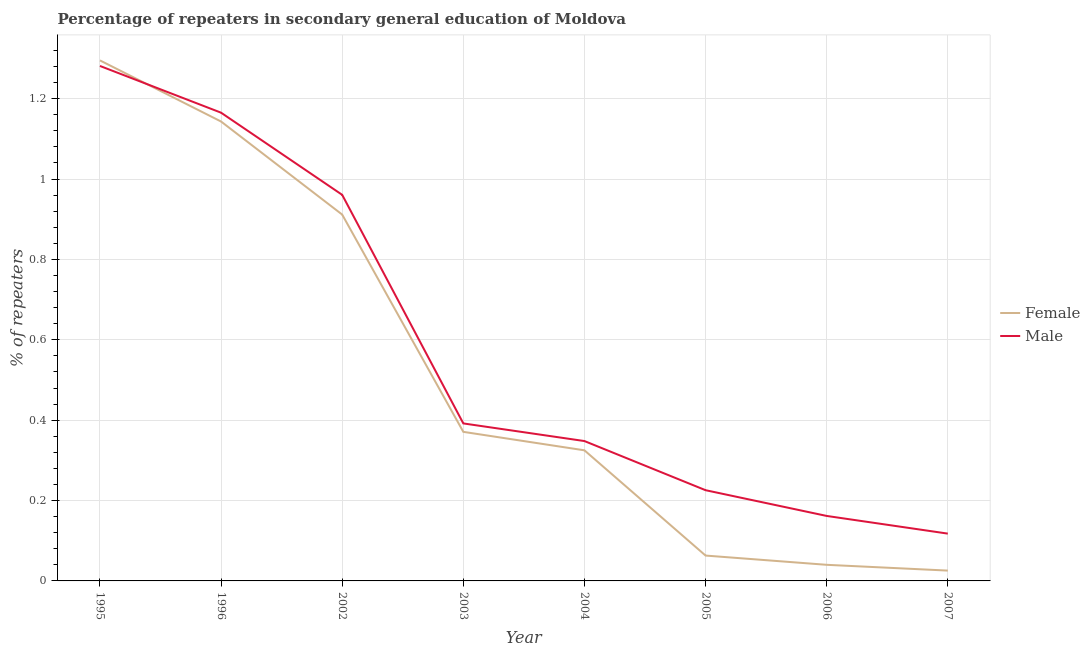Does the line corresponding to percentage of male repeaters intersect with the line corresponding to percentage of female repeaters?
Give a very brief answer. Yes. What is the percentage of male repeaters in 2002?
Ensure brevity in your answer.  0.96. Across all years, what is the maximum percentage of female repeaters?
Give a very brief answer. 1.3. Across all years, what is the minimum percentage of male repeaters?
Keep it short and to the point. 0.12. In which year was the percentage of female repeaters maximum?
Keep it short and to the point. 1995. In which year was the percentage of female repeaters minimum?
Ensure brevity in your answer.  2007. What is the total percentage of male repeaters in the graph?
Your answer should be compact. 4.65. What is the difference between the percentage of female repeaters in 1996 and that in 2004?
Give a very brief answer. 0.82. What is the difference between the percentage of female repeaters in 1996 and the percentage of male repeaters in 2006?
Ensure brevity in your answer.  0.98. What is the average percentage of male repeaters per year?
Offer a terse response. 0.58. In the year 2004, what is the difference between the percentage of male repeaters and percentage of female repeaters?
Your answer should be compact. 0.02. In how many years, is the percentage of female repeaters greater than 1.08 %?
Make the answer very short. 2. What is the ratio of the percentage of female repeaters in 2006 to that in 2007?
Offer a very short reply. 1.56. Is the percentage of female repeaters in 1995 less than that in 2003?
Your response must be concise. No. What is the difference between the highest and the second highest percentage of male repeaters?
Ensure brevity in your answer.  0.12. What is the difference between the highest and the lowest percentage of female repeaters?
Give a very brief answer. 1.27. Does the percentage of male repeaters monotonically increase over the years?
Keep it short and to the point. No. Is the percentage of male repeaters strictly greater than the percentage of female repeaters over the years?
Provide a short and direct response. No. Is the percentage of female repeaters strictly less than the percentage of male repeaters over the years?
Offer a terse response. No. Are the values on the major ticks of Y-axis written in scientific E-notation?
Your answer should be very brief. No. Does the graph contain grids?
Offer a terse response. Yes. How many legend labels are there?
Offer a terse response. 2. How are the legend labels stacked?
Provide a short and direct response. Vertical. What is the title of the graph?
Offer a terse response. Percentage of repeaters in secondary general education of Moldova. Does "Lowest 20% of population" appear as one of the legend labels in the graph?
Make the answer very short. No. What is the label or title of the Y-axis?
Give a very brief answer. % of repeaters. What is the % of repeaters of Female in 1995?
Keep it short and to the point. 1.3. What is the % of repeaters in Male in 1995?
Offer a terse response. 1.28. What is the % of repeaters in Female in 1996?
Ensure brevity in your answer.  1.14. What is the % of repeaters in Male in 1996?
Your response must be concise. 1.17. What is the % of repeaters of Female in 2002?
Offer a terse response. 0.91. What is the % of repeaters in Male in 2002?
Provide a succinct answer. 0.96. What is the % of repeaters in Female in 2003?
Ensure brevity in your answer.  0.37. What is the % of repeaters in Male in 2003?
Provide a short and direct response. 0.39. What is the % of repeaters of Female in 2004?
Your answer should be compact. 0.32. What is the % of repeaters of Male in 2004?
Give a very brief answer. 0.35. What is the % of repeaters in Female in 2005?
Make the answer very short. 0.06. What is the % of repeaters in Male in 2005?
Provide a short and direct response. 0.23. What is the % of repeaters in Female in 2006?
Your response must be concise. 0.04. What is the % of repeaters of Male in 2006?
Make the answer very short. 0.16. What is the % of repeaters in Female in 2007?
Offer a terse response. 0.03. What is the % of repeaters of Male in 2007?
Your response must be concise. 0.12. Across all years, what is the maximum % of repeaters in Female?
Provide a succinct answer. 1.3. Across all years, what is the maximum % of repeaters of Male?
Provide a succinct answer. 1.28. Across all years, what is the minimum % of repeaters in Female?
Offer a terse response. 0.03. Across all years, what is the minimum % of repeaters of Male?
Provide a short and direct response. 0.12. What is the total % of repeaters in Female in the graph?
Provide a short and direct response. 4.17. What is the total % of repeaters of Male in the graph?
Your answer should be compact. 4.65. What is the difference between the % of repeaters in Female in 1995 and that in 1996?
Make the answer very short. 0.15. What is the difference between the % of repeaters of Male in 1995 and that in 1996?
Offer a terse response. 0.12. What is the difference between the % of repeaters of Female in 1995 and that in 2002?
Give a very brief answer. 0.38. What is the difference between the % of repeaters in Male in 1995 and that in 2002?
Your answer should be very brief. 0.32. What is the difference between the % of repeaters in Female in 1995 and that in 2003?
Ensure brevity in your answer.  0.92. What is the difference between the % of repeaters in Male in 1995 and that in 2003?
Provide a short and direct response. 0.89. What is the difference between the % of repeaters in Female in 1995 and that in 2004?
Ensure brevity in your answer.  0.97. What is the difference between the % of repeaters in Female in 1995 and that in 2005?
Your answer should be very brief. 1.23. What is the difference between the % of repeaters in Male in 1995 and that in 2005?
Keep it short and to the point. 1.06. What is the difference between the % of repeaters of Female in 1995 and that in 2006?
Offer a very short reply. 1.26. What is the difference between the % of repeaters in Male in 1995 and that in 2006?
Offer a very short reply. 1.12. What is the difference between the % of repeaters of Female in 1995 and that in 2007?
Keep it short and to the point. 1.27. What is the difference between the % of repeaters in Male in 1995 and that in 2007?
Offer a terse response. 1.16. What is the difference between the % of repeaters in Female in 1996 and that in 2002?
Ensure brevity in your answer.  0.23. What is the difference between the % of repeaters of Male in 1996 and that in 2002?
Make the answer very short. 0.2. What is the difference between the % of repeaters in Female in 1996 and that in 2003?
Offer a terse response. 0.77. What is the difference between the % of repeaters of Male in 1996 and that in 2003?
Your answer should be very brief. 0.77. What is the difference between the % of repeaters in Female in 1996 and that in 2004?
Provide a succinct answer. 0.82. What is the difference between the % of repeaters in Male in 1996 and that in 2004?
Ensure brevity in your answer.  0.82. What is the difference between the % of repeaters of Female in 1996 and that in 2005?
Your response must be concise. 1.08. What is the difference between the % of repeaters of Male in 1996 and that in 2005?
Your answer should be very brief. 0.94. What is the difference between the % of repeaters of Female in 1996 and that in 2006?
Offer a terse response. 1.1. What is the difference between the % of repeaters in Male in 1996 and that in 2006?
Make the answer very short. 1. What is the difference between the % of repeaters of Female in 1996 and that in 2007?
Make the answer very short. 1.12. What is the difference between the % of repeaters of Male in 1996 and that in 2007?
Provide a short and direct response. 1.05. What is the difference between the % of repeaters of Female in 2002 and that in 2003?
Ensure brevity in your answer.  0.54. What is the difference between the % of repeaters in Male in 2002 and that in 2003?
Offer a very short reply. 0.57. What is the difference between the % of repeaters of Female in 2002 and that in 2004?
Ensure brevity in your answer.  0.59. What is the difference between the % of repeaters of Male in 2002 and that in 2004?
Offer a very short reply. 0.61. What is the difference between the % of repeaters of Female in 2002 and that in 2005?
Keep it short and to the point. 0.85. What is the difference between the % of repeaters of Male in 2002 and that in 2005?
Offer a terse response. 0.73. What is the difference between the % of repeaters of Female in 2002 and that in 2006?
Ensure brevity in your answer.  0.87. What is the difference between the % of repeaters of Male in 2002 and that in 2006?
Your answer should be compact. 0.8. What is the difference between the % of repeaters of Female in 2002 and that in 2007?
Your answer should be compact. 0.89. What is the difference between the % of repeaters of Male in 2002 and that in 2007?
Your answer should be very brief. 0.84. What is the difference between the % of repeaters in Female in 2003 and that in 2004?
Offer a very short reply. 0.05. What is the difference between the % of repeaters of Male in 2003 and that in 2004?
Your response must be concise. 0.04. What is the difference between the % of repeaters in Female in 2003 and that in 2005?
Provide a short and direct response. 0.31. What is the difference between the % of repeaters in Male in 2003 and that in 2005?
Provide a short and direct response. 0.17. What is the difference between the % of repeaters in Female in 2003 and that in 2006?
Your response must be concise. 0.33. What is the difference between the % of repeaters of Male in 2003 and that in 2006?
Give a very brief answer. 0.23. What is the difference between the % of repeaters of Female in 2003 and that in 2007?
Your answer should be very brief. 0.35. What is the difference between the % of repeaters of Male in 2003 and that in 2007?
Provide a succinct answer. 0.27. What is the difference between the % of repeaters of Female in 2004 and that in 2005?
Offer a terse response. 0.26. What is the difference between the % of repeaters in Male in 2004 and that in 2005?
Your answer should be very brief. 0.12. What is the difference between the % of repeaters in Female in 2004 and that in 2006?
Give a very brief answer. 0.28. What is the difference between the % of repeaters of Male in 2004 and that in 2006?
Give a very brief answer. 0.19. What is the difference between the % of repeaters of Female in 2004 and that in 2007?
Your answer should be compact. 0.3. What is the difference between the % of repeaters of Male in 2004 and that in 2007?
Your answer should be very brief. 0.23. What is the difference between the % of repeaters in Female in 2005 and that in 2006?
Give a very brief answer. 0.02. What is the difference between the % of repeaters in Male in 2005 and that in 2006?
Ensure brevity in your answer.  0.06. What is the difference between the % of repeaters in Female in 2005 and that in 2007?
Provide a succinct answer. 0.04. What is the difference between the % of repeaters of Male in 2005 and that in 2007?
Your answer should be compact. 0.11. What is the difference between the % of repeaters of Female in 2006 and that in 2007?
Make the answer very short. 0.01. What is the difference between the % of repeaters in Male in 2006 and that in 2007?
Offer a very short reply. 0.04. What is the difference between the % of repeaters of Female in 1995 and the % of repeaters of Male in 1996?
Offer a terse response. 0.13. What is the difference between the % of repeaters in Female in 1995 and the % of repeaters in Male in 2002?
Your answer should be very brief. 0.33. What is the difference between the % of repeaters in Female in 1995 and the % of repeaters in Male in 2003?
Make the answer very short. 0.9. What is the difference between the % of repeaters of Female in 1995 and the % of repeaters of Male in 2004?
Your answer should be compact. 0.95. What is the difference between the % of repeaters in Female in 1995 and the % of repeaters in Male in 2005?
Provide a succinct answer. 1.07. What is the difference between the % of repeaters in Female in 1995 and the % of repeaters in Male in 2006?
Your response must be concise. 1.13. What is the difference between the % of repeaters in Female in 1995 and the % of repeaters in Male in 2007?
Offer a very short reply. 1.18. What is the difference between the % of repeaters of Female in 1996 and the % of repeaters of Male in 2002?
Your answer should be compact. 0.18. What is the difference between the % of repeaters in Female in 1996 and the % of repeaters in Male in 2003?
Your response must be concise. 0.75. What is the difference between the % of repeaters of Female in 1996 and the % of repeaters of Male in 2004?
Give a very brief answer. 0.8. What is the difference between the % of repeaters in Female in 1996 and the % of repeaters in Male in 2005?
Offer a terse response. 0.92. What is the difference between the % of repeaters of Female in 1996 and the % of repeaters of Male in 2006?
Keep it short and to the point. 0.98. What is the difference between the % of repeaters in Female in 1996 and the % of repeaters in Male in 2007?
Provide a short and direct response. 1.03. What is the difference between the % of repeaters of Female in 2002 and the % of repeaters of Male in 2003?
Ensure brevity in your answer.  0.52. What is the difference between the % of repeaters of Female in 2002 and the % of repeaters of Male in 2004?
Offer a terse response. 0.56. What is the difference between the % of repeaters in Female in 2002 and the % of repeaters in Male in 2005?
Provide a succinct answer. 0.69. What is the difference between the % of repeaters in Female in 2002 and the % of repeaters in Male in 2006?
Your response must be concise. 0.75. What is the difference between the % of repeaters in Female in 2002 and the % of repeaters in Male in 2007?
Ensure brevity in your answer.  0.79. What is the difference between the % of repeaters in Female in 2003 and the % of repeaters in Male in 2004?
Offer a terse response. 0.02. What is the difference between the % of repeaters of Female in 2003 and the % of repeaters of Male in 2005?
Offer a terse response. 0.15. What is the difference between the % of repeaters of Female in 2003 and the % of repeaters of Male in 2006?
Offer a very short reply. 0.21. What is the difference between the % of repeaters of Female in 2003 and the % of repeaters of Male in 2007?
Offer a very short reply. 0.25. What is the difference between the % of repeaters of Female in 2004 and the % of repeaters of Male in 2005?
Give a very brief answer. 0.1. What is the difference between the % of repeaters of Female in 2004 and the % of repeaters of Male in 2006?
Your answer should be compact. 0.16. What is the difference between the % of repeaters of Female in 2004 and the % of repeaters of Male in 2007?
Provide a succinct answer. 0.21. What is the difference between the % of repeaters of Female in 2005 and the % of repeaters of Male in 2006?
Your response must be concise. -0.1. What is the difference between the % of repeaters of Female in 2005 and the % of repeaters of Male in 2007?
Make the answer very short. -0.05. What is the difference between the % of repeaters in Female in 2006 and the % of repeaters in Male in 2007?
Offer a terse response. -0.08. What is the average % of repeaters in Female per year?
Provide a short and direct response. 0.52. What is the average % of repeaters of Male per year?
Your answer should be compact. 0.58. In the year 1995, what is the difference between the % of repeaters in Female and % of repeaters in Male?
Provide a short and direct response. 0.01. In the year 1996, what is the difference between the % of repeaters in Female and % of repeaters in Male?
Provide a succinct answer. -0.02. In the year 2002, what is the difference between the % of repeaters of Female and % of repeaters of Male?
Provide a succinct answer. -0.05. In the year 2003, what is the difference between the % of repeaters in Female and % of repeaters in Male?
Offer a very short reply. -0.02. In the year 2004, what is the difference between the % of repeaters of Female and % of repeaters of Male?
Offer a very short reply. -0.02. In the year 2005, what is the difference between the % of repeaters in Female and % of repeaters in Male?
Your answer should be compact. -0.16. In the year 2006, what is the difference between the % of repeaters of Female and % of repeaters of Male?
Provide a succinct answer. -0.12. In the year 2007, what is the difference between the % of repeaters in Female and % of repeaters in Male?
Offer a very short reply. -0.09. What is the ratio of the % of repeaters of Female in 1995 to that in 1996?
Make the answer very short. 1.13. What is the ratio of the % of repeaters of Male in 1995 to that in 1996?
Offer a very short reply. 1.1. What is the ratio of the % of repeaters of Female in 1995 to that in 2002?
Your answer should be compact. 1.42. What is the ratio of the % of repeaters of Male in 1995 to that in 2002?
Provide a succinct answer. 1.33. What is the ratio of the % of repeaters of Female in 1995 to that in 2003?
Provide a succinct answer. 3.49. What is the ratio of the % of repeaters in Male in 1995 to that in 2003?
Your answer should be compact. 3.27. What is the ratio of the % of repeaters of Female in 1995 to that in 2004?
Give a very brief answer. 3.99. What is the ratio of the % of repeaters of Male in 1995 to that in 2004?
Your answer should be very brief. 3.68. What is the ratio of the % of repeaters in Female in 1995 to that in 2005?
Your response must be concise. 20.53. What is the ratio of the % of repeaters in Male in 1995 to that in 2005?
Your response must be concise. 5.68. What is the ratio of the % of repeaters in Female in 1995 to that in 2006?
Give a very brief answer. 32.31. What is the ratio of the % of repeaters of Male in 1995 to that in 2006?
Provide a succinct answer. 7.92. What is the ratio of the % of repeaters in Female in 1995 to that in 2007?
Provide a short and direct response. 50.44. What is the ratio of the % of repeaters in Male in 1995 to that in 2007?
Your answer should be compact. 10.89. What is the ratio of the % of repeaters in Female in 1996 to that in 2002?
Provide a short and direct response. 1.25. What is the ratio of the % of repeaters in Male in 1996 to that in 2002?
Your answer should be very brief. 1.21. What is the ratio of the % of repeaters of Female in 1996 to that in 2003?
Provide a succinct answer. 3.08. What is the ratio of the % of repeaters of Male in 1996 to that in 2003?
Keep it short and to the point. 2.97. What is the ratio of the % of repeaters in Female in 1996 to that in 2004?
Make the answer very short. 3.52. What is the ratio of the % of repeaters of Male in 1996 to that in 2004?
Keep it short and to the point. 3.35. What is the ratio of the % of repeaters in Female in 1996 to that in 2005?
Offer a very short reply. 18.12. What is the ratio of the % of repeaters in Male in 1996 to that in 2005?
Ensure brevity in your answer.  5.16. What is the ratio of the % of repeaters of Female in 1996 to that in 2006?
Offer a very short reply. 28.52. What is the ratio of the % of repeaters in Male in 1996 to that in 2006?
Keep it short and to the point. 7.21. What is the ratio of the % of repeaters of Female in 1996 to that in 2007?
Offer a terse response. 44.51. What is the ratio of the % of repeaters of Male in 1996 to that in 2007?
Offer a terse response. 9.9. What is the ratio of the % of repeaters in Female in 2002 to that in 2003?
Offer a terse response. 2.46. What is the ratio of the % of repeaters in Male in 2002 to that in 2003?
Offer a terse response. 2.45. What is the ratio of the % of repeaters in Female in 2002 to that in 2004?
Make the answer very short. 2.81. What is the ratio of the % of repeaters in Male in 2002 to that in 2004?
Make the answer very short. 2.76. What is the ratio of the % of repeaters in Female in 2002 to that in 2005?
Make the answer very short. 14.45. What is the ratio of the % of repeaters of Male in 2002 to that in 2005?
Keep it short and to the point. 4.26. What is the ratio of the % of repeaters of Female in 2002 to that in 2006?
Offer a terse response. 22.74. What is the ratio of the % of repeaters of Male in 2002 to that in 2006?
Your answer should be compact. 5.94. What is the ratio of the % of repeaters of Female in 2002 to that in 2007?
Offer a very short reply. 35.49. What is the ratio of the % of repeaters in Male in 2002 to that in 2007?
Keep it short and to the point. 8.16. What is the ratio of the % of repeaters of Female in 2003 to that in 2004?
Keep it short and to the point. 1.14. What is the ratio of the % of repeaters of Male in 2003 to that in 2004?
Make the answer very short. 1.13. What is the ratio of the % of repeaters in Female in 2003 to that in 2005?
Provide a succinct answer. 5.88. What is the ratio of the % of repeaters of Male in 2003 to that in 2005?
Ensure brevity in your answer.  1.74. What is the ratio of the % of repeaters of Female in 2003 to that in 2006?
Provide a short and direct response. 9.25. What is the ratio of the % of repeaters in Male in 2003 to that in 2006?
Offer a very short reply. 2.42. What is the ratio of the % of repeaters of Female in 2003 to that in 2007?
Your answer should be very brief. 14.44. What is the ratio of the % of repeaters of Male in 2003 to that in 2007?
Offer a very short reply. 3.33. What is the ratio of the % of repeaters in Female in 2004 to that in 2005?
Offer a very short reply. 5.15. What is the ratio of the % of repeaters in Male in 2004 to that in 2005?
Provide a short and direct response. 1.54. What is the ratio of the % of repeaters in Female in 2004 to that in 2006?
Ensure brevity in your answer.  8.11. What is the ratio of the % of repeaters in Male in 2004 to that in 2006?
Give a very brief answer. 2.15. What is the ratio of the % of repeaters in Female in 2004 to that in 2007?
Provide a short and direct response. 12.65. What is the ratio of the % of repeaters of Male in 2004 to that in 2007?
Make the answer very short. 2.96. What is the ratio of the % of repeaters in Female in 2005 to that in 2006?
Provide a succinct answer. 1.57. What is the ratio of the % of repeaters of Male in 2005 to that in 2006?
Offer a terse response. 1.4. What is the ratio of the % of repeaters in Female in 2005 to that in 2007?
Ensure brevity in your answer.  2.46. What is the ratio of the % of repeaters of Male in 2005 to that in 2007?
Make the answer very short. 1.92. What is the ratio of the % of repeaters in Female in 2006 to that in 2007?
Offer a very short reply. 1.56. What is the ratio of the % of repeaters in Male in 2006 to that in 2007?
Provide a short and direct response. 1.37. What is the difference between the highest and the second highest % of repeaters in Female?
Your response must be concise. 0.15. What is the difference between the highest and the second highest % of repeaters in Male?
Your answer should be compact. 0.12. What is the difference between the highest and the lowest % of repeaters of Female?
Keep it short and to the point. 1.27. What is the difference between the highest and the lowest % of repeaters in Male?
Keep it short and to the point. 1.16. 